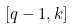<formula> <loc_0><loc_0><loc_500><loc_500>[ q - 1 , k ]</formula> 